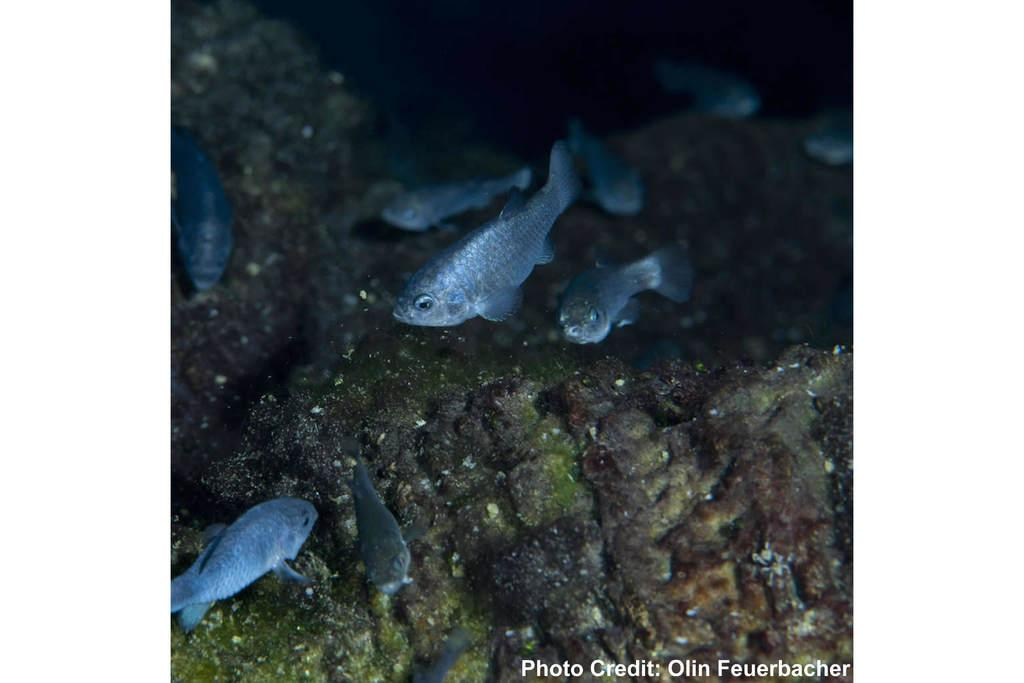What type of animals can be seen in the water in the image? There are fishes in the water in the image. Is there any text present in the image? Yes, there is a text in the bottom right of the image. How does the society in the image react to the wilderness? There is no society or wilderness present in the image; it features fishes in the water and a text in the bottom right. 